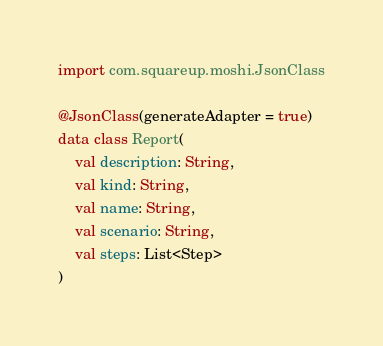<code> <loc_0><loc_0><loc_500><loc_500><_Kotlin_>import com.squareup.moshi.JsonClass

@JsonClass(generateAdapter = true)
data class Report(
    val description: String,
    val kind: String,
    val name: String,
    val scenario: String,
    val steps: List<Step>
)
</code> 